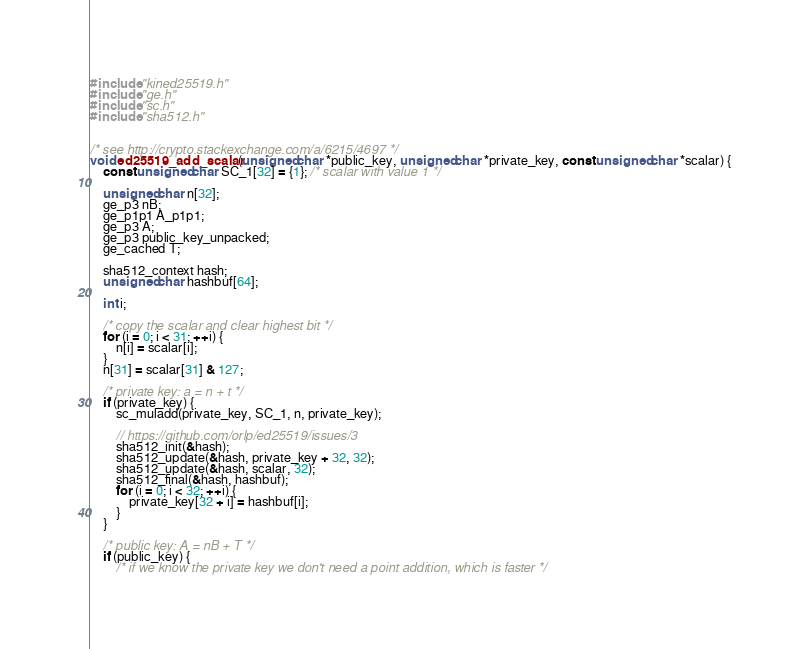Convert code to text. <code><loc_0><loc_0><loc_500><loc_500><_C_>#include "kined25519.h"
#include "ge.h"
#include "sc.h"
#include "sha512.h"


/* see http://crypto.stackexchange.com/a/6215/4697 */
void ed25519_add_scalar(unsigned char *public_key, unsigned char *private_key, const unsigned char *scalar) {
    const unsigned char SC_1[32] = {1}; /* scalar with value 1 */
    
    unsigned char n[32]; 
    ge_p3 nB;
    ge_p1p1 A_p1p1;
    ge_p3 A;
    ge_p3 public_key_unpacked;
    ge_cached T;

    sha512_context hash;
    unsigned char hashbuf[64];

    int i;

    /* copy the scalar and clear highest bit */
    for (i = 0; i < 31; ++i) {
        n[i] = scalar[i];
    }
    n[31] = scalar[31] & 127;

    /* private key: a = n + t */
    if (private_key) {
        sc_muladd(private_key, SC_1, n, private_key);

        // https://github.com/orlp/ed25519/issues/3
        sha512_init(&hash);
        sha512_update(&hash, private_key + 32, 32);
        sha512_update(&hash, scalar, 32);
        sha512_final(&hash, hashbuf);
        for (i = 0; i < 32; ++i) {
            private_key[32 + i] = hashbuf[i];
        }
    }

    /* public key: A = nB + T */
    if (public_key) {
        /* if we know the private key we don't need a point addition, which is faster */</code> 